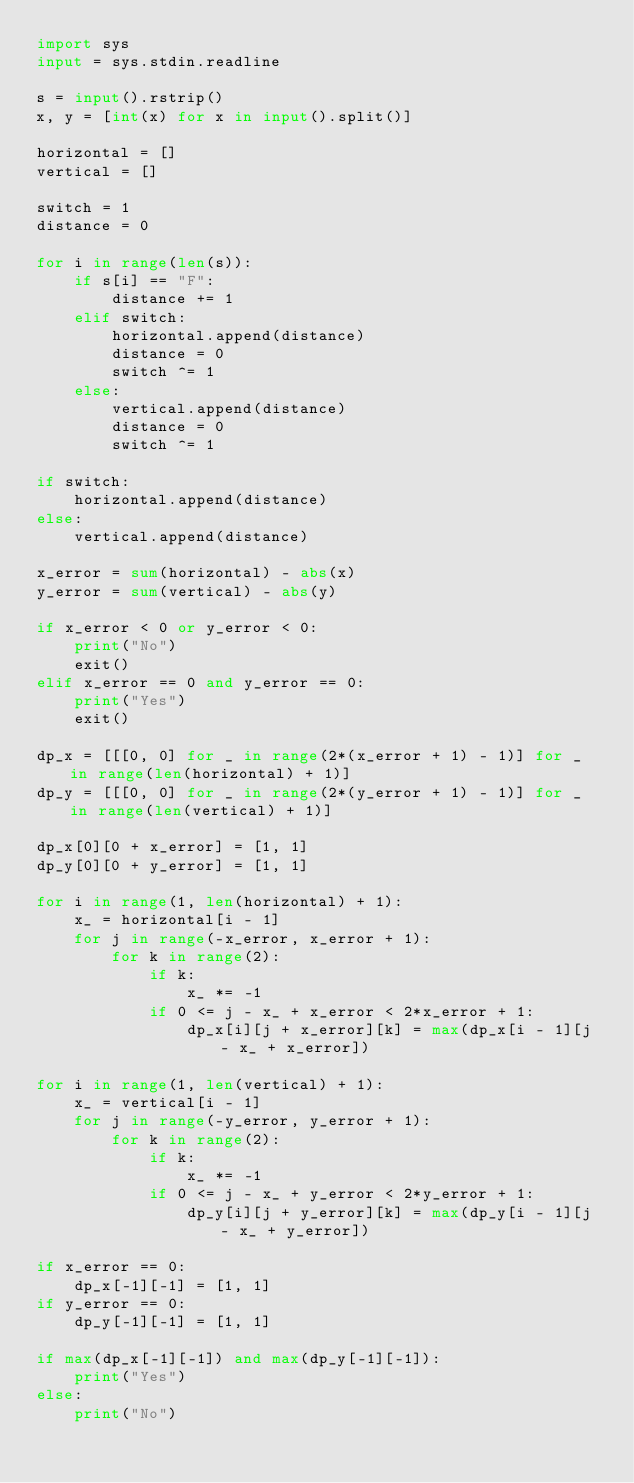Convert code to text. <code><loc_0><loc_0><loc_500><loc_500><_Python_>import sys
input = sys.stdin.readline

s = input().rstrip()
x, y = [int(x) for x in input().split()]

horizontal = []
vertical = []

switch = 1
distance = 0

for i in range(len(s)):
    if s[i] == "F":
        distance += 1
    elif switch:
        horizontal.append(distance)
        distance = 0
        switch ^= 1
    else:
        vertical.append(distance)
        distance = 0
        switch ^= 1

if switch:
    horizontal.append(distance)
else:
    vertical.append(distance)

x_error = sum(horizontal) - abs(x)
y_error = sum(vertical) - abs(y)

if x_error < 0 or y_error < 0:
    print("No")
    exit()
elif x_error == 0 and y_error == 0:
    print("Yes")
    exit()

dp_x = [[[0, 0] for _ in range(2*(x_error + 1) - 1)] for _ in range(len(horizontal) + 1)]
dp_y = [[[0, 0] for _ in range(2*(y_error + 1) - 1)] for _ in range(len(vertical) + 1)]

dp_x[0][0 + x_error] = [1, 1]
dp_y[0][0 + y_error] = [1, 1]

for i in range(1, len(horizontal) + 1):
    x_ = horizontal[i - 1]
    for j in range(-x_error, x_error + 1):
        for k in range(2):
            if k:
                x_ *= -1
            if 0 <= j - x_ + x_error < 2*x_error + 1:
                dp_x[i][j + x_error][k] = max(dp_x[i - 1][j - x_ + x_error])

for i in range(1, len(vertical) + 1):
    x_ = vertical[i - 1]
    for j in range(-y_error, y_error + 1):
        for k in range(2):
            if k:
                x_ *= -1
            if 0 <= j - x_ + y_error < 2*y_error + 1:
                dp_y[i][j + y_error][k] = max(dp_y[i - 1][j - x_ + y_error])

if x_error == 0:
    dp_x[-1][-1] = [1, 1]
if y_error == 0:
    dp_y[-1][-1] = [1, 1]

if max(dp_x[-1][-1]) and max(dp_y[-1][-1]):
    print("Yes")
else:
    print("No")</code> 